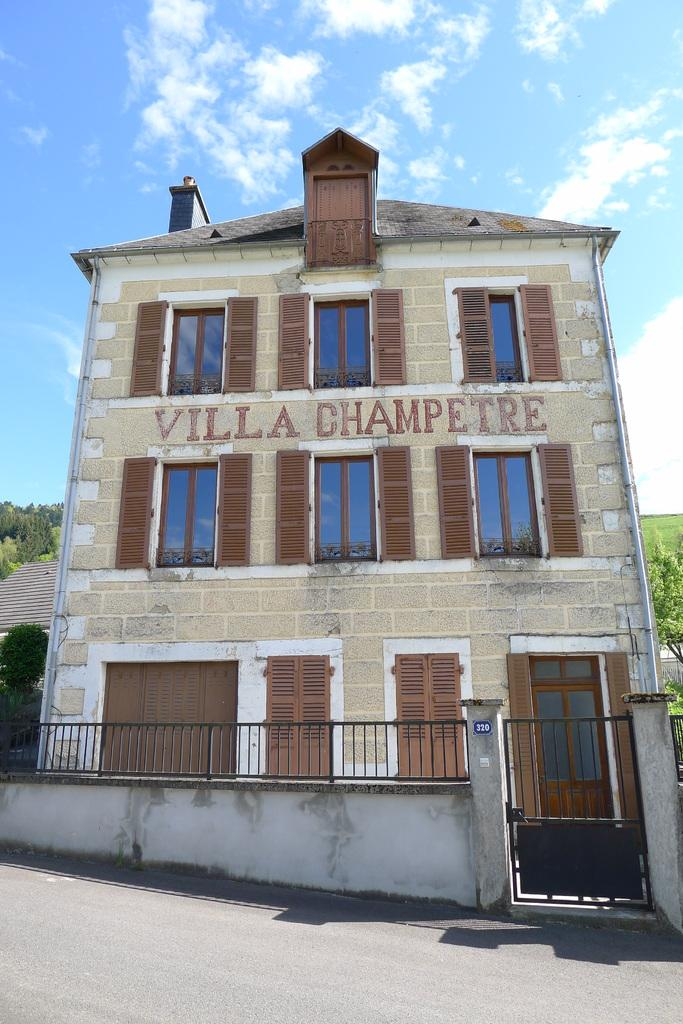What type of structure can be seen in the image? There is a building in the image. What is located near the building? There is a wall with a metal gate in the image. What type of vegetation is visible in the image? There are trees visible in the image. What other type of structure can be seen in the image? There is a house on the side in the image. How would you describe the weather based on the sky in the image? The sky is blue and cloudy in the image, suggesting a partly cloudy day. How does the pollution in the image affect the trees? There is no indication of pollution in the image, so we cannot determine its effect on the trees. Can you explain how the house joins the building in the image? The house and the building are separate structures in the image, so they do not join each other. 